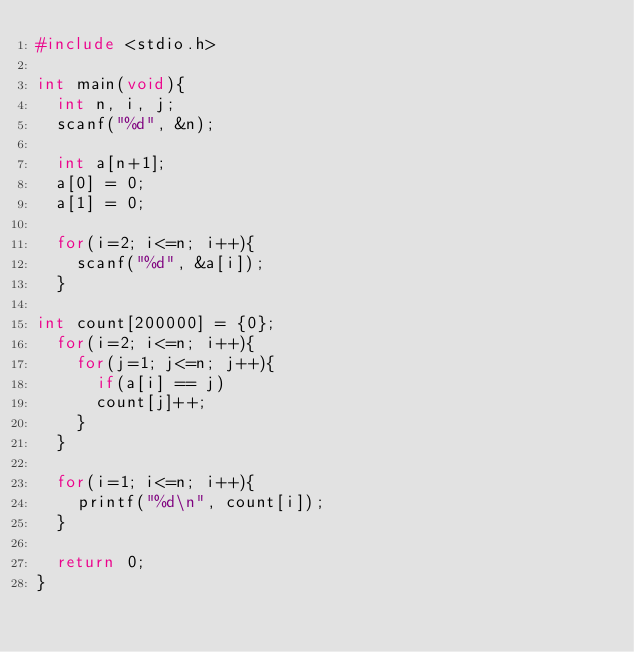<code> <loc_0><loc_0><loc_500><loc_500><_C_>#include <stdio.h>
 
int main(void){
  int n, i, j;
  scanf("%d", &n);

  int a[n+1];
  a[0] = 0;
  a[1] = 0;

  for(i=2; i<=n; i++){
    scanf("%d", &a[i]);
  }

int count[200000] = {0};
  for(i=2; i<=n; i++){
    for(j=1; j<=n; j++){
      if(a[i] == j)
      count[j]++;
    }
  }

  for(i=1; i<=n; i++){
    printf("%d\n", count[i]);
  }

  return 0;
}</code> 